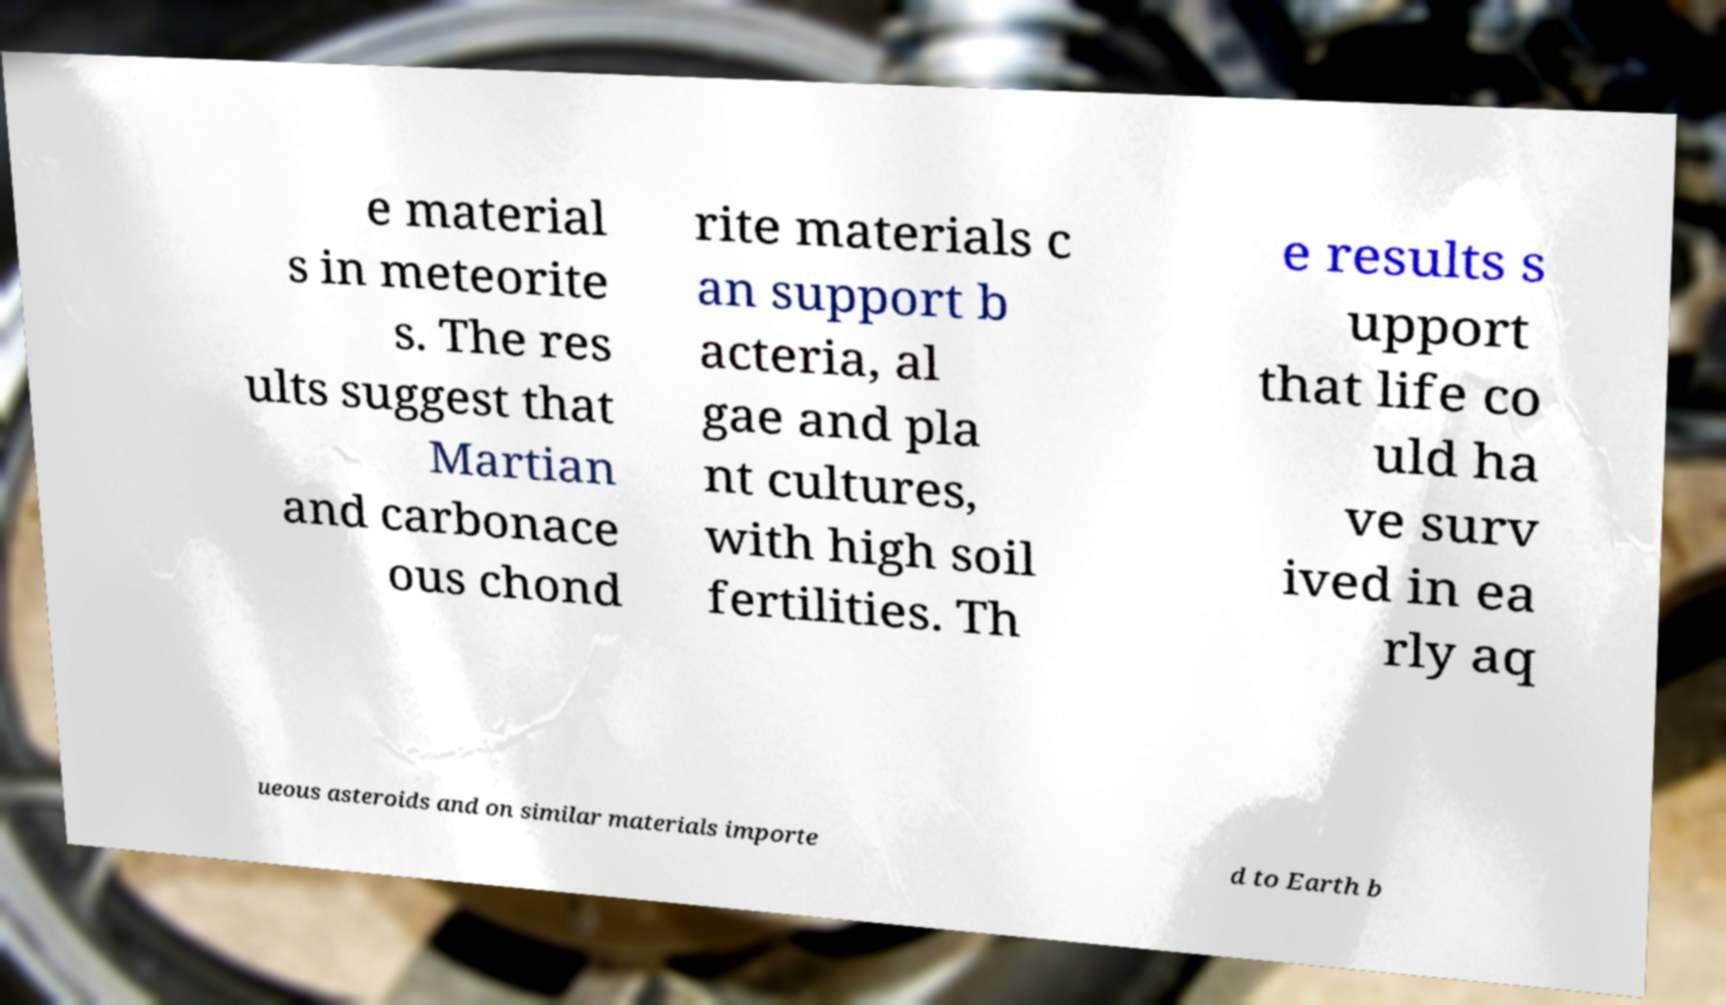There's text embedded in this image that I need extracted. Can you transcribe it verbatim? e material s in meteorite s. The res ults suggest that Martian and carbonace ous chond rite materials c an support b acteria, al gae and pla nt cultures, with high soil fertilities. Th e results s upport that life co uld ha ve surv ived in ea rly aq ueous asteroids and on similar materials importe d to Earth b 